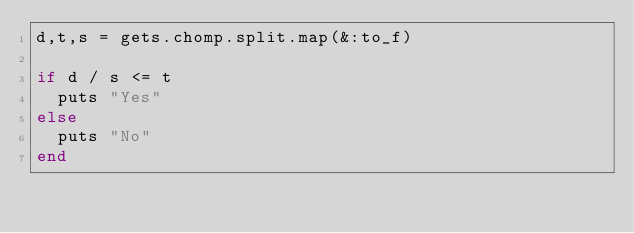Convert code to text. <code><loc_0><loc_0><loc_500><loc_500><_Ruby_>d,t,s = gets.chomp.split.map(&:to_f)

if d / s <= t
  puts "Yes"
else
  puts "No"
end</code> 